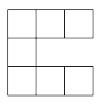$7$ congruent squares are arranged into a 'C,' as shown below. If the perimeter and area of the 'C' are equal (ignoring units), compute the (nonzero) side length of the squares.\n Answer is $\boxed{\frac{16}{7}}$. 